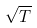Convert formula to latex. <formula><loc_0><loc_0><loc_500><loc_500>\sqrt { T }</formula> 